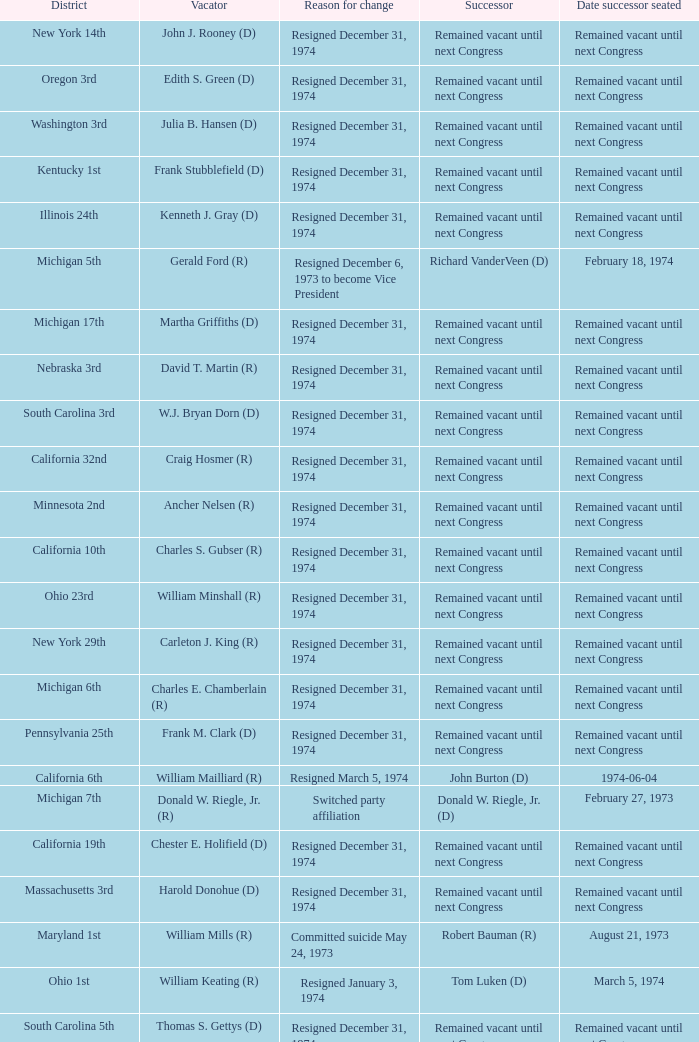What was the district when the reason for change was died January 1, 1974? California 13th. 